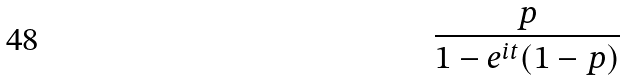Convert formula to latex. <formula><loc_0><loc_0><loc_500><loc_500>\frac { p } { 1 - e ^ { i t } ( 1 - p ) }</formula> 